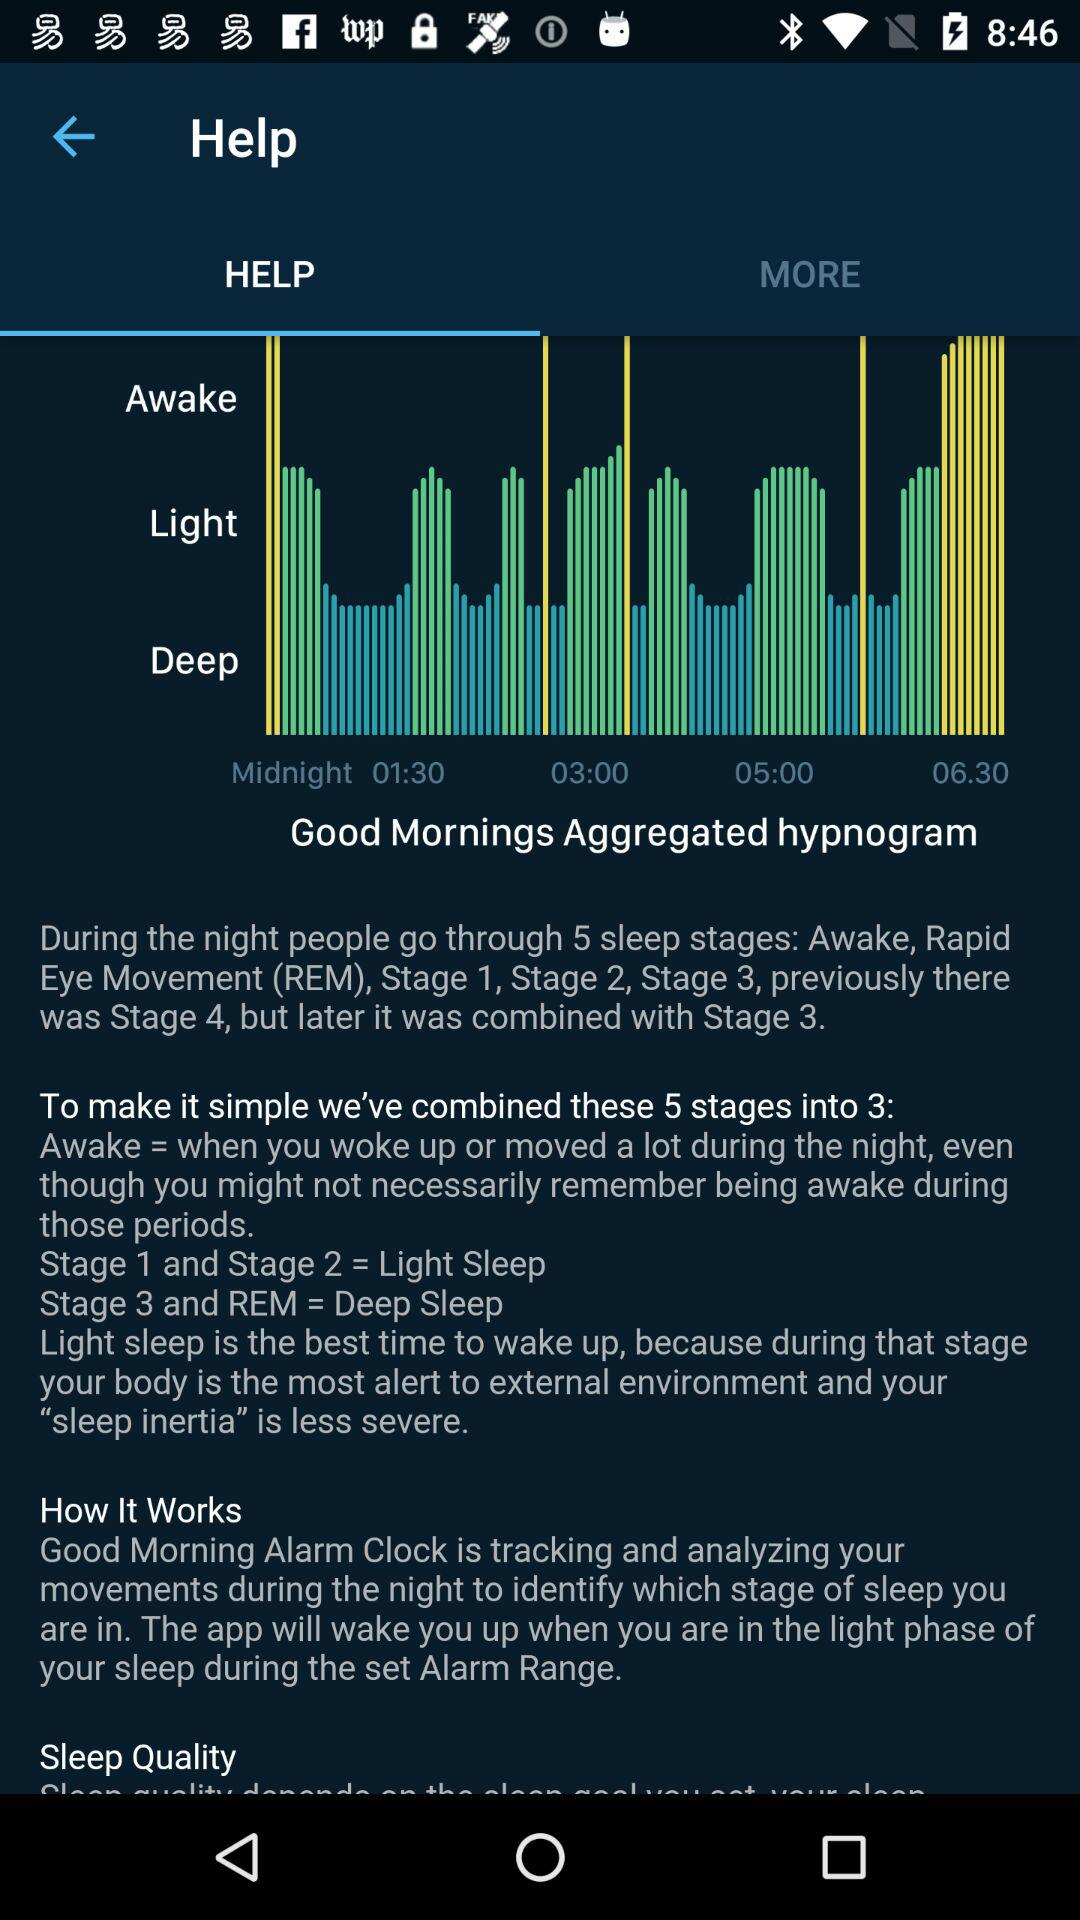Which tab is selected? The selected tab is "HELP". 